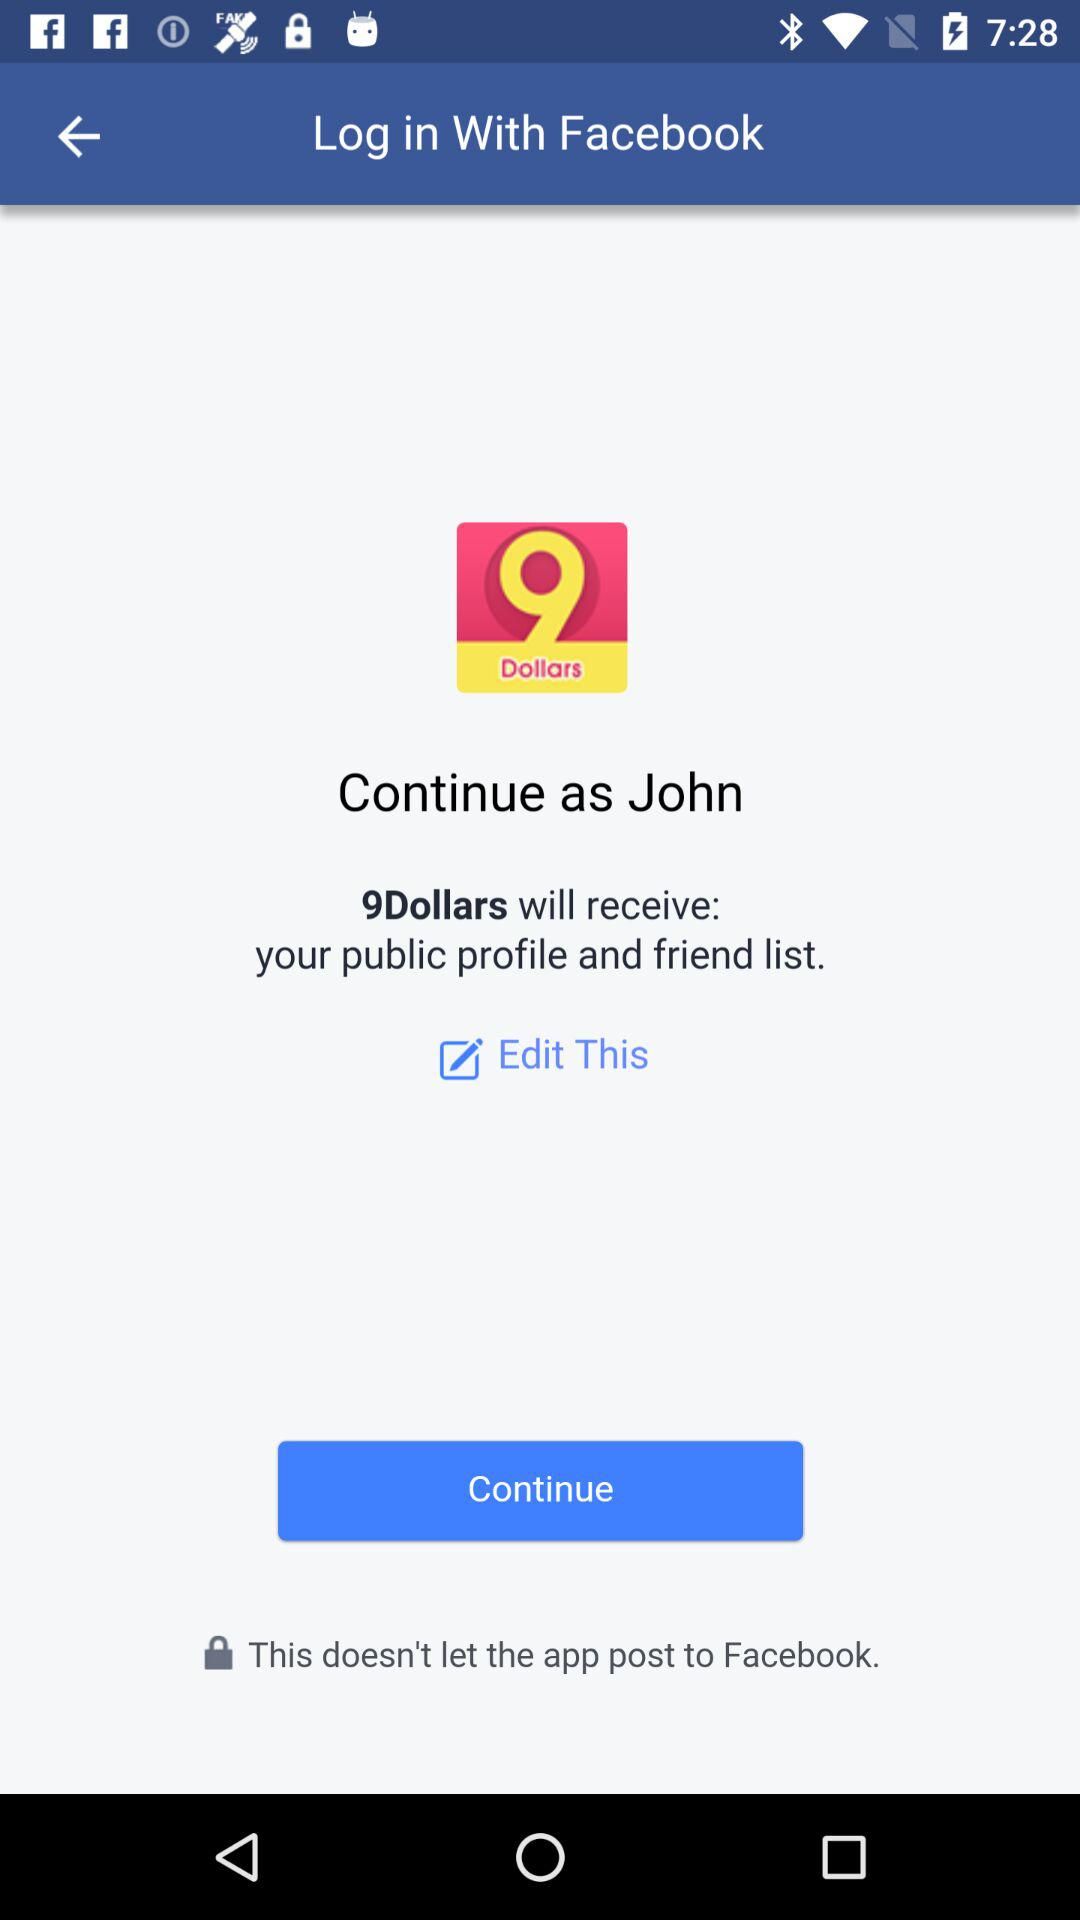What is the name of the user? The name of the user is John. 